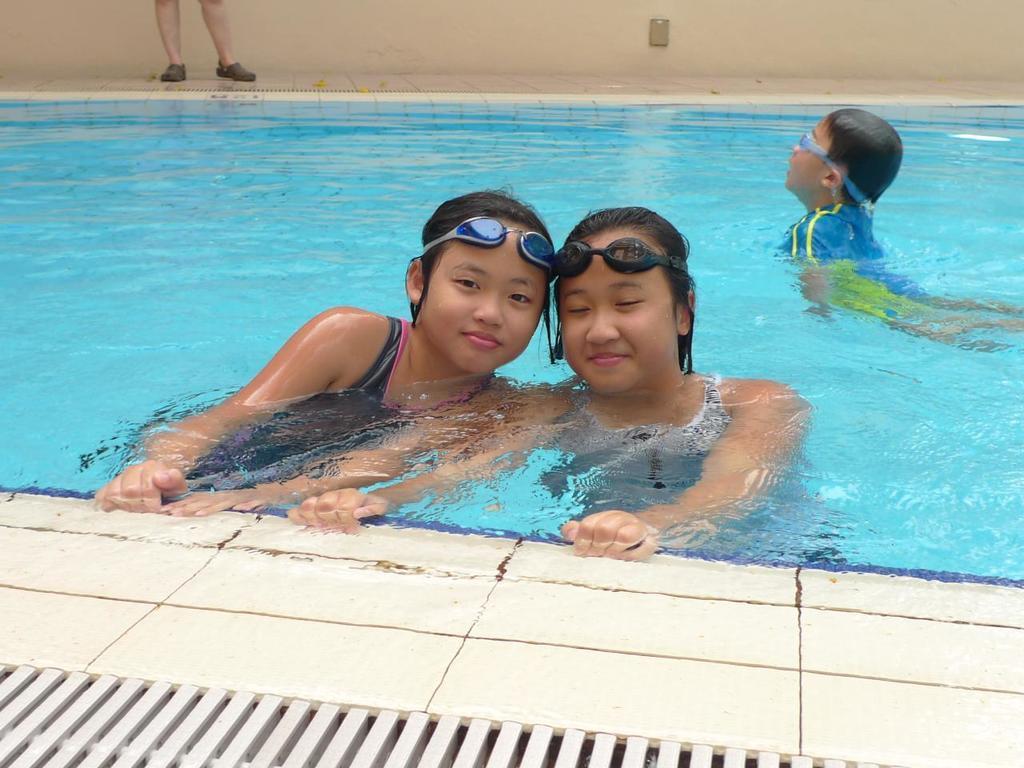Please provide a concise description of this image. In the background we can see the person legs, wall and an object. In this picture we can see a boy wearing goggles and swimming. In this picture we can see the swimming pool and the girls giving a pose. At the bottom portion of the picture we can see the floor and metal grille. 